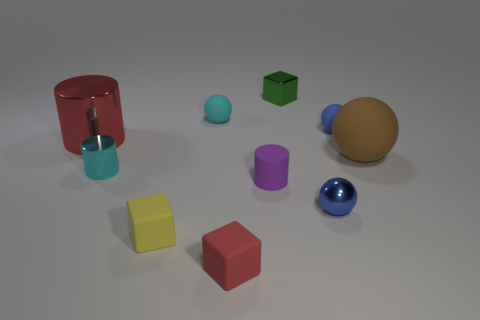Subtract all blue balls. How many were subtracted if there are1blue balls left? 1 Subtract 1 cylinders. How many cylinders are left? 2 Subtract all large brown balls. How many balls are left? 3 Subtract all gray spheres. Subtract all blue cylinders. How many spheres are left? 4 Subtract all blocks. How many objects are left? 7 Add 4 red matte objects. How many red matte objects exist? 5 Subtract 0 green cylinders. How many objects are left? 10 Subtract all large yellow matte cylinders. Subtract all large red metallic things. How many objects are left? 9 Add 1 green shiny cubes. How many green shiny cubes are left? 2 